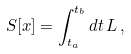<formula> <loc_0><loc_0><loc_500><loc_500>S [ { x } ] = \int _ { t _ { a } } ^ { t _ { b } } d t \, L \, ,</formula> 